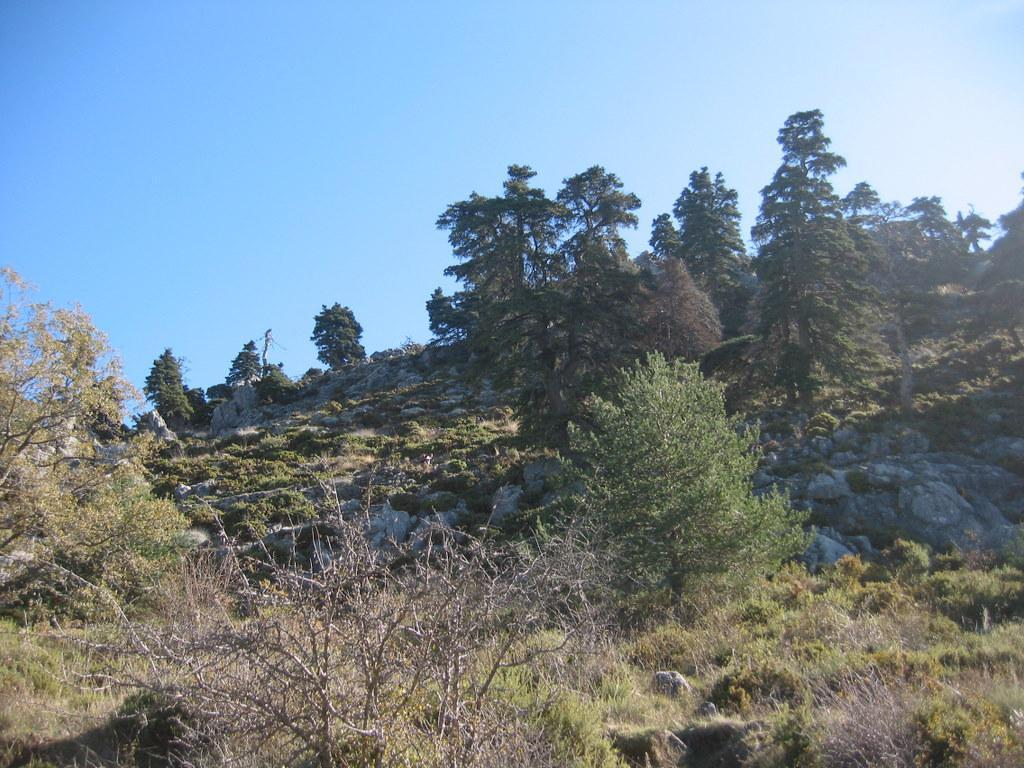What type of vegetation can be seen in the image? There are plants and trees in the image. What other natural elements are present in the image? There are rocks in the image. What can be seen in the background of the image? The sky is visible in the background of the image. What type of letters are being delivered by the bears in the image? There are no bears or letters present in the image. 